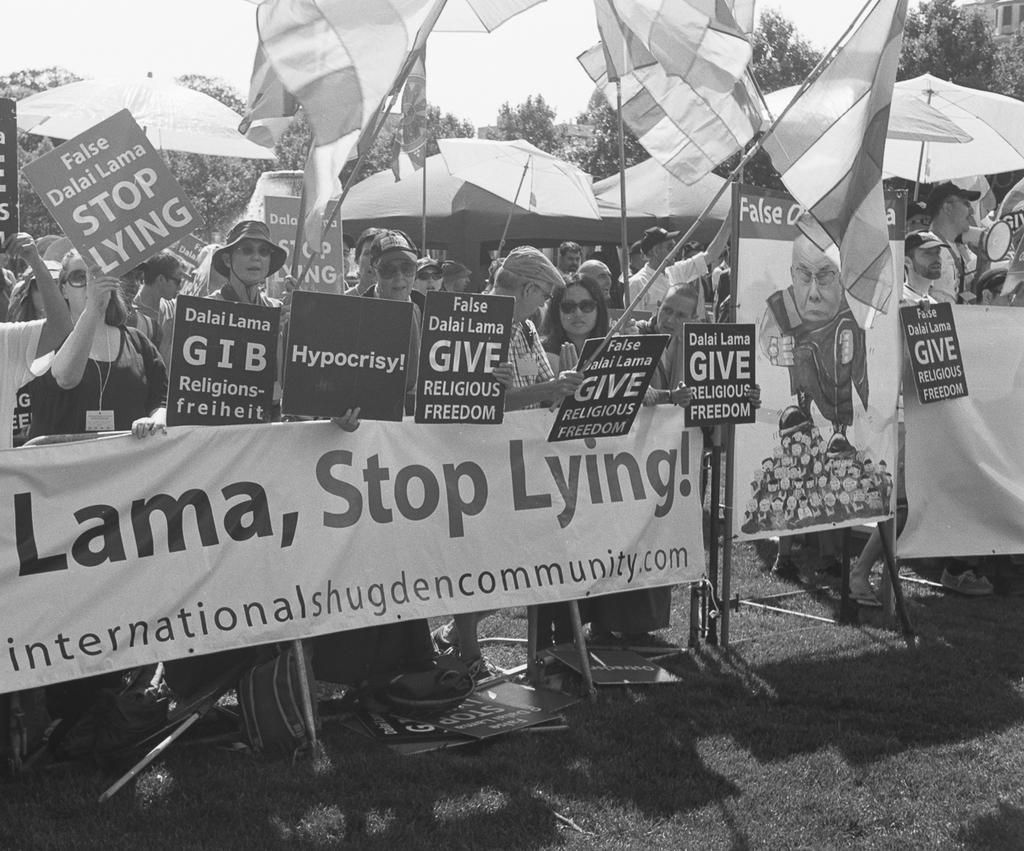How would you summarize this image in a sentence or two? In this image we can see people standing and holding boards. There are banners and we can see flags. In the background there are trees and sky. 